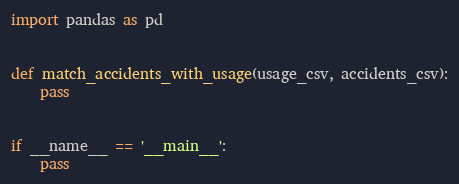Convert code to text. <code><loc_0><loc_0><loc_500><loc_500><_Python_>import pandas as pd


def match_accidents_with_usage(usage_csv, accidents_csv):
    pass


if __name__ == '__main__':
    pass

</code> 